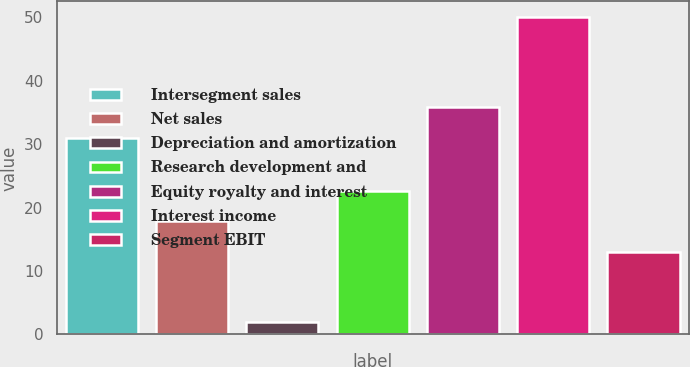Convert chart. <chart><loc_0><loc_0><loc_500><loc_500><bar_chart><fcel>Intersegment sales<fcel>Net sales<fcel>Depreciation and amortization<fcel>Research development and<fcel>Equity royalty and interest<fcel>Interest income<fcel>Segment EBIT<nl><fcel>31<fcel>17.8<fcel>2<fcel>22.6<fcel>35.8<fcel>50<fcel>13<nl></chart> 